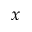Convert formula to latex. <formula><loc_0><loc_0><loc_500><loc_500>x</formula> 